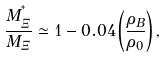<formula> <loc_0><loc_0><loc_500><loc_500>\frac { M _ { \Xi } ^ { ^ { * } } } { M _ { \Xi } } \simeq 1 - 0 . 0 4 \left ( \frac { \rho _ { B } } { \rho _ { 0 } } \right ) ,</formula> 